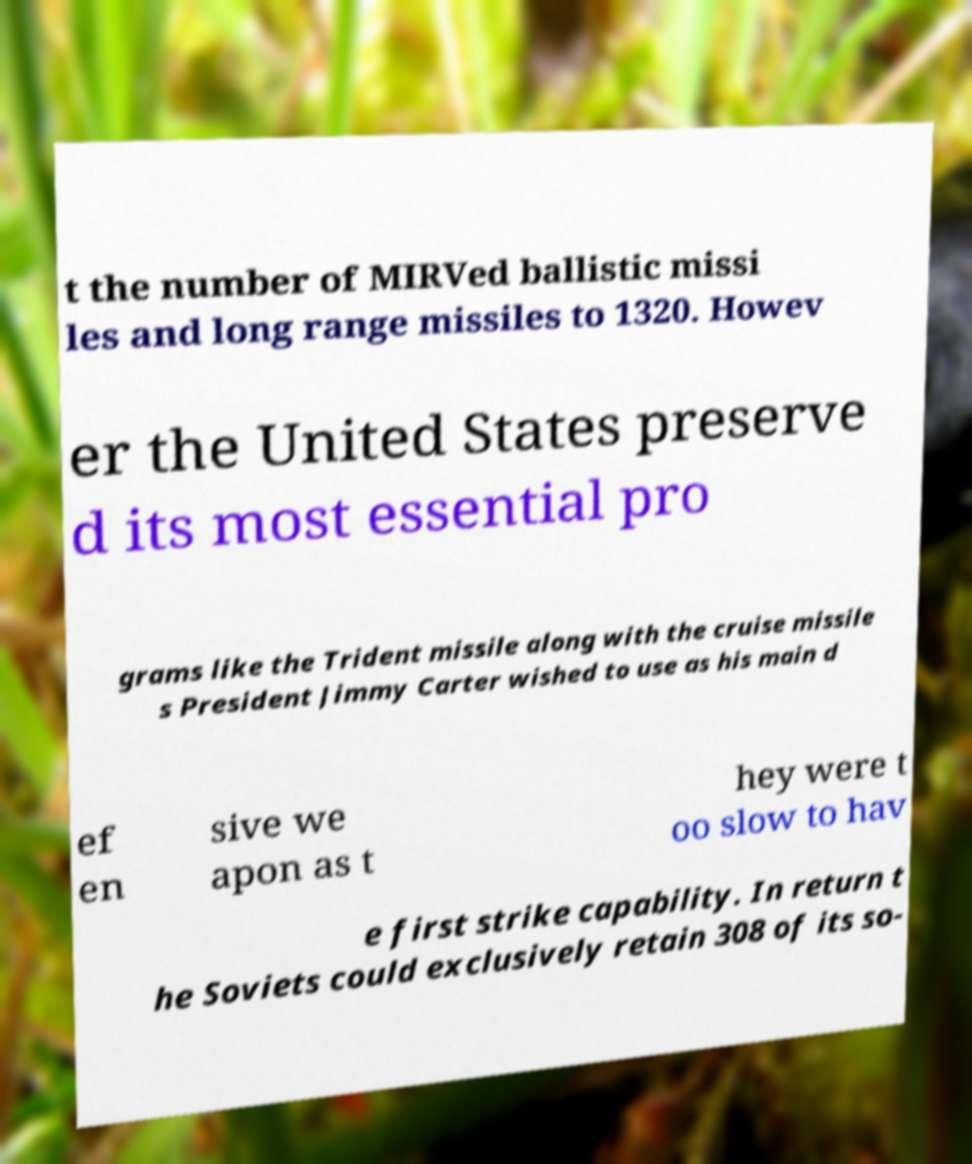I need the written content from this picture converted into text. Can you do that? t the number of MIRVed ballistic missi les and long range missiles to 1320. Howev er the United States preserve d its most essential pro grams like the Trident missile along with the cruise missile s President Jimmy Carter wished to use as his main d ef en sive we apon as t hey were t oo slow to hav e first strike capability. In return t he Soviets could exclusively retain 308 of its so- 